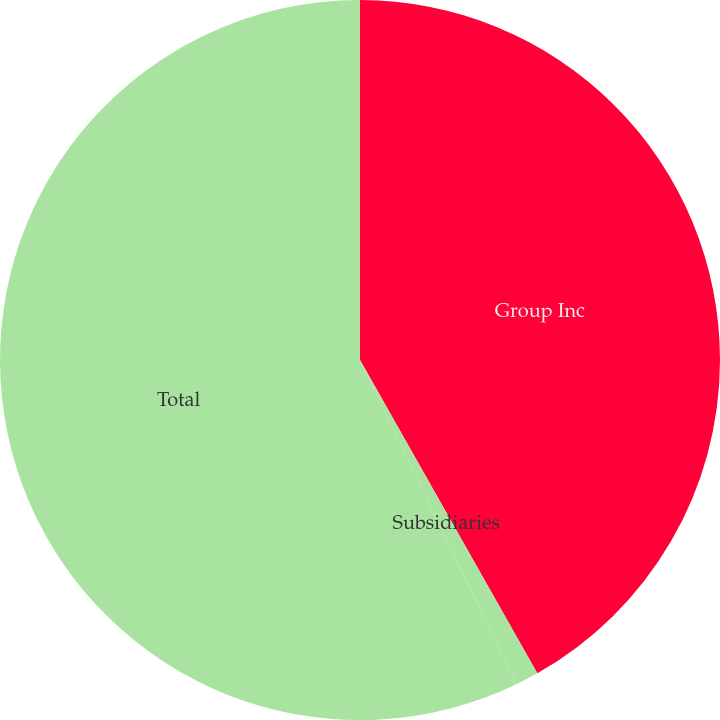Convert chart to OTSL. <chart><loc_0><loc_0><loc_500><loc_500><pie_chart><fcel>Group Inc<fcel>Subsidiaries<fcel>Total<nl><fcel>41.8%<fcel>1.04%<fcel>57.15%<nl></chart> 